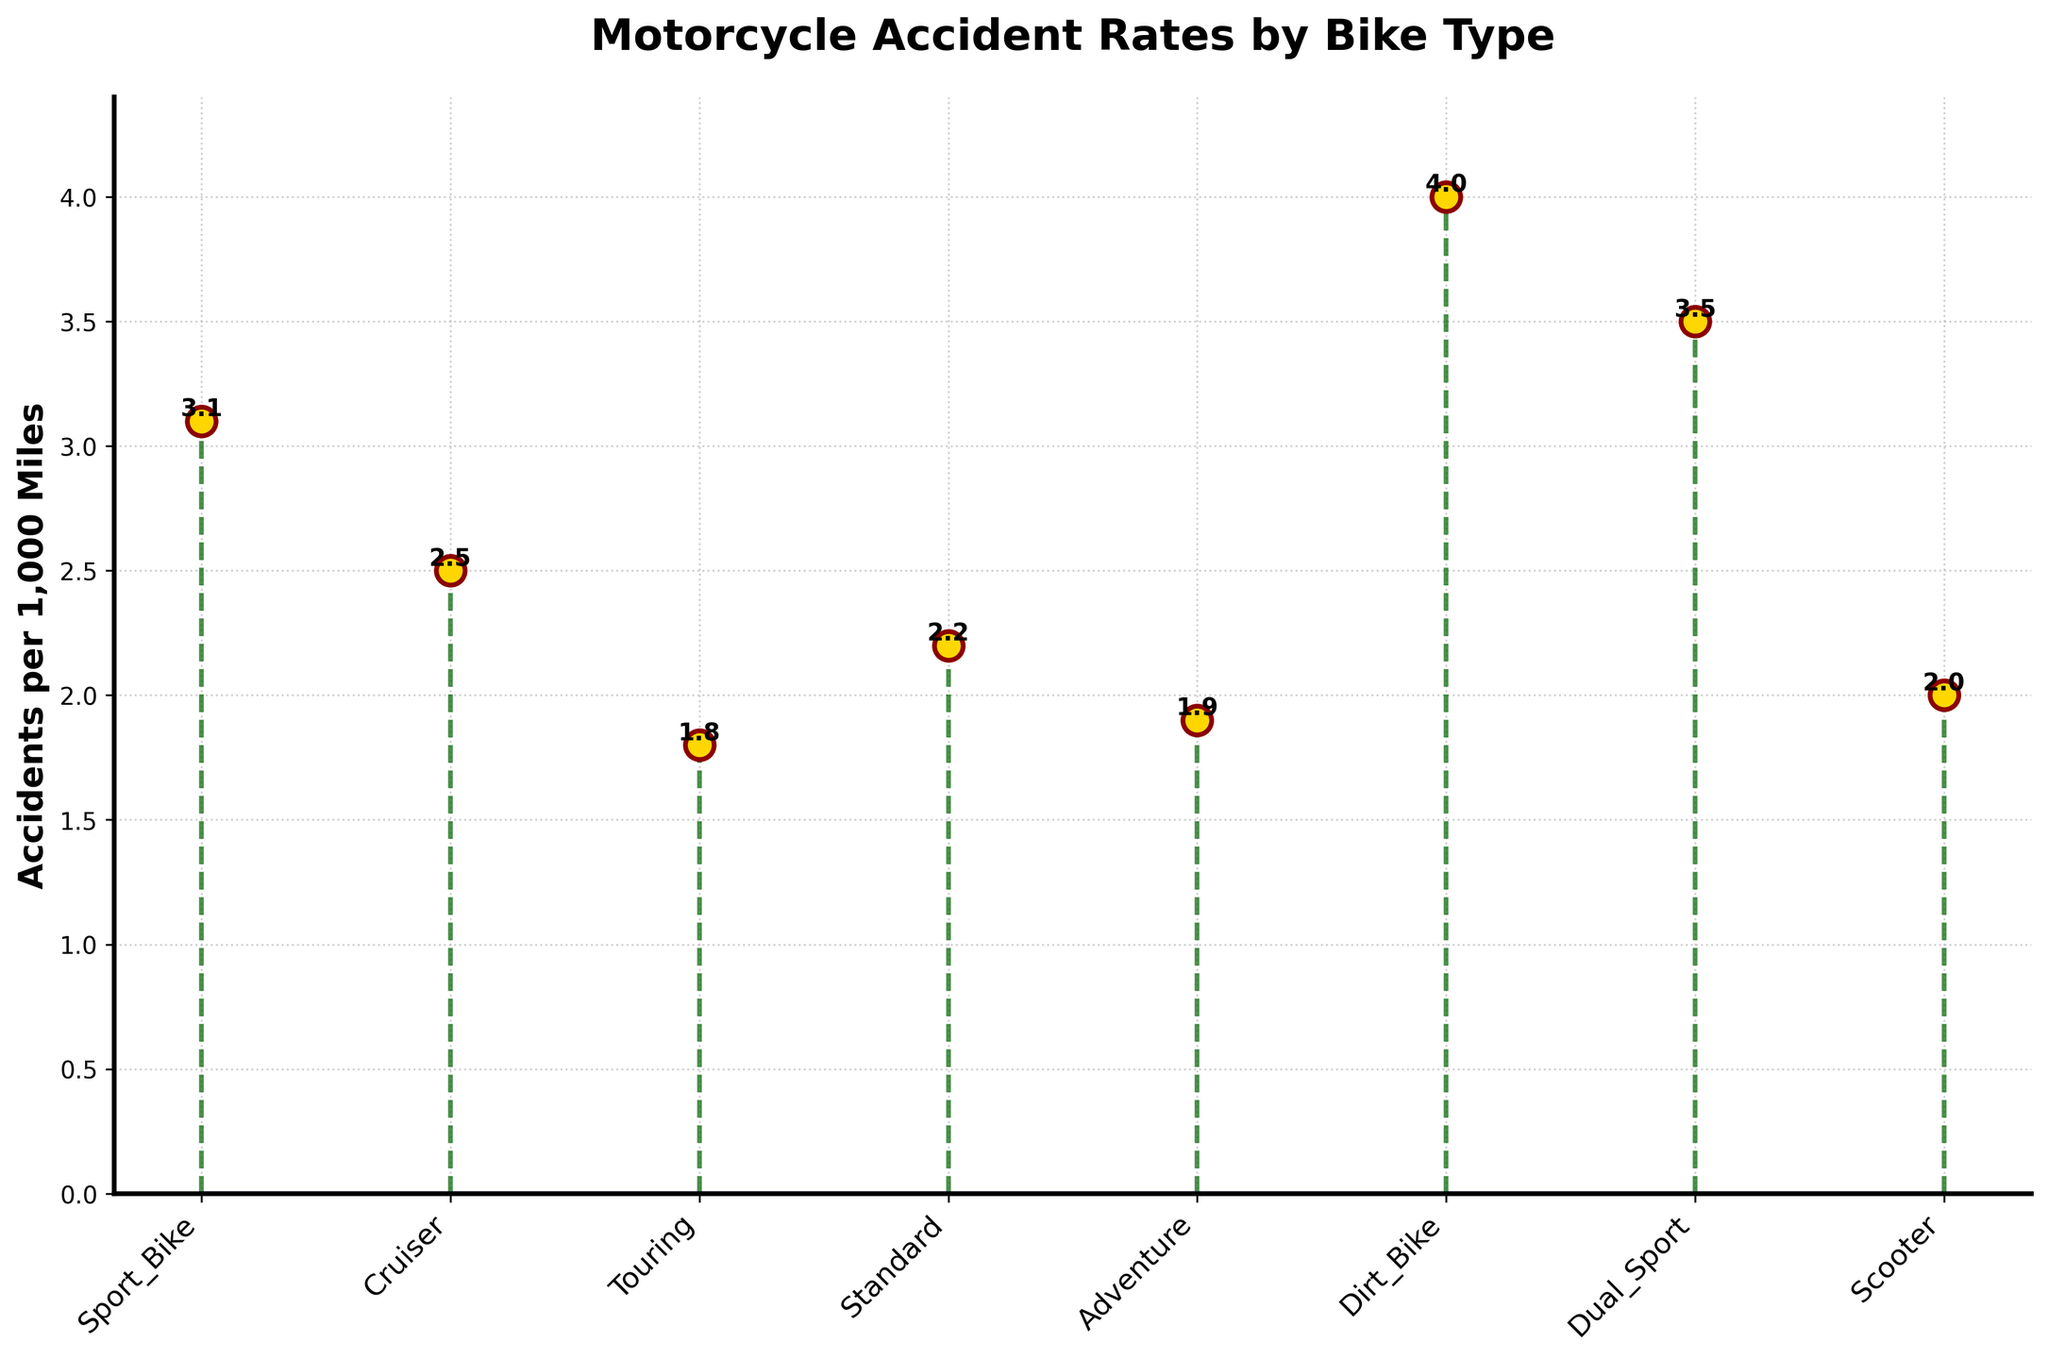What is the title of the figure? The title of the figure is usually displayed at the top of the chart. Look there to find the specific words used.
Answer: Motorcycle Accident Rates by Bike Type What are the labels on the y-axis? The y-axis label provides context for what the plotted values represent. Here, it's described as a rate of incidents per a certain distance.
Answer: Accidents per 1,000 Miles Which bike type has the highest accident rate? The highest point in the stem plot indicates the bike type with the highest accidents per 1,000 miles. Identify which x-tick label corresponds to the highest y-value.
Answer: Dirt Bike What bike type has the lowest accident rate? Look for the shortest stem in the plot and find out which x-tick label it corresponds to. It represents the bike type with the lowest accidents per 1,000 miles.
Answer: Touring How many different bike types are shown in the plot? Count the number of different x-tick labels to determine the number of bike types presented.
Answer: 8 What is the difference in accident rates between Sport Bike and Scooter? Find both values indicated by the stems and subtract the lower value (Scooter) from the higher value (Sport Bike) to get the difference.
Answer: 1.1 What is the average accident rate of all bike types? Sum the accident rates of all bike types and then divide by the number of bike types to find the average.
Answer: 7.6 / 8 = 2.7 Which bike types have an accident rate greater than 3? Look at the stems whose length exceeds 3 units on the y-axis and note their corresponding x-tick labels.
Answer: Sport Bike, Dirt Bike, Dual Sport Is the baseline of the plot colored? If so, what color is it? The baseline's color is usually referenced in the description or can be seen visually beneath the stems.
Answer: Yes, navy What is the range of the accident rates shown in the plot? Subtract the smallest accident rate from the largest accident rate to determine the range.
Answer: 4.0 - 1.8 = 2.2 